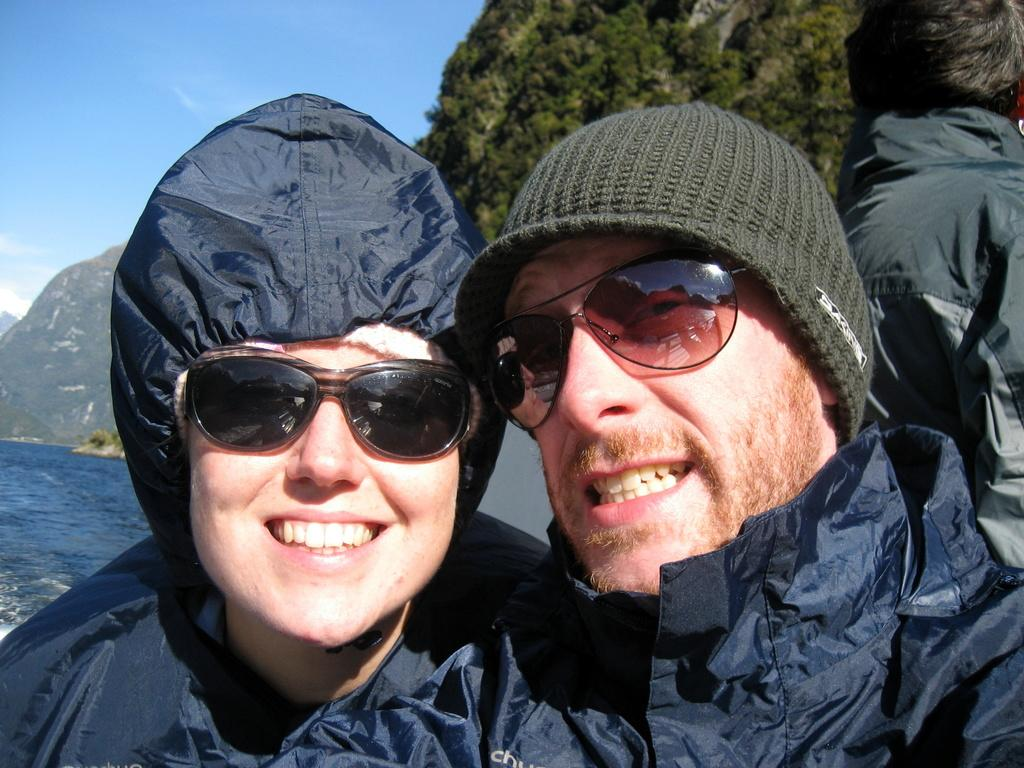How many people are in the image? There are a few people in the image. What is visible in the image besides the people? There is water, hills, trees, a plant, and the sky visible in the image. Can you describe the landscape in the image? The image features hills and trees, with water visible in the foreground. What is the plant in the image? The plant in the image is not specified, but it is present. What type of apparatus is being used by the spy in the image? There is no spy or apparatus present in the image. What flavor of jelly is being consumed by the people in the image? There is no jelly visible in the image; it only features a few people, water, hills, trees, a plant, and the sky. 